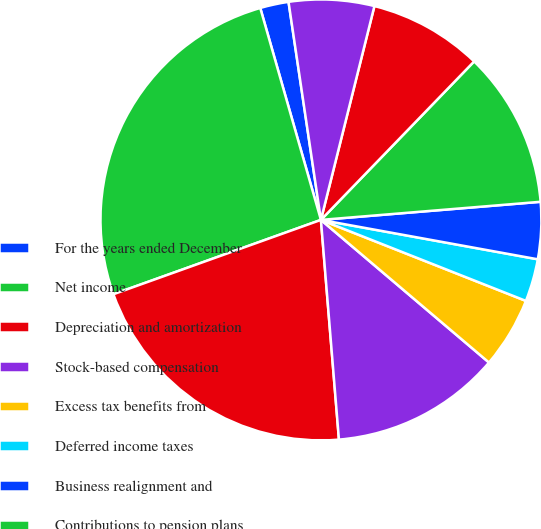<chart> <loc_0><loc_0><loc_500><loc_500><pie_chart><fcel>For the years ended December<fcel>Net income<fcel>Depreciation and amortization<fcel>Stock-based compensation<fcel>Excess tax benefits from<fcel>Deferred income taxes<fcel>Business realignment and<fcel>Contributions to pension plans<fcel>Accounts receivable-trade<fcel>Inventories<nl><fcel>2.09%<fcel>26.04%<fcel>20.83%<fcel>12.5%<fcel>5.21%<fcel>3.13%<fcel>4.17%<fcel>11.46%<fcel>8.33%<fcel>6.25%<nl></chart> 